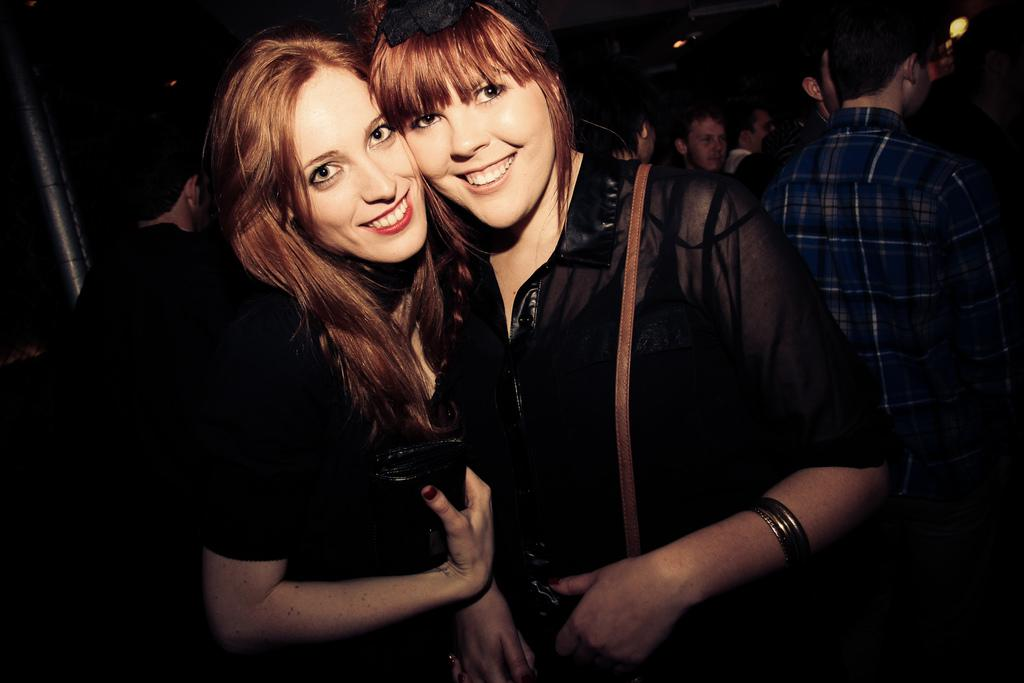How many women are in the image? There are two women in the image. What expression do the women have? The women are smiling. Can you describe the people in the background? There is a group of people standing in the background. What is the color of the background in the image? The background is dark. Where is the shelf located in the image? There is no shelf present in the image. How many friends are visible in the image? The term "friends" is not mentioned in the provided facts, so it cannot be determined from the image. 